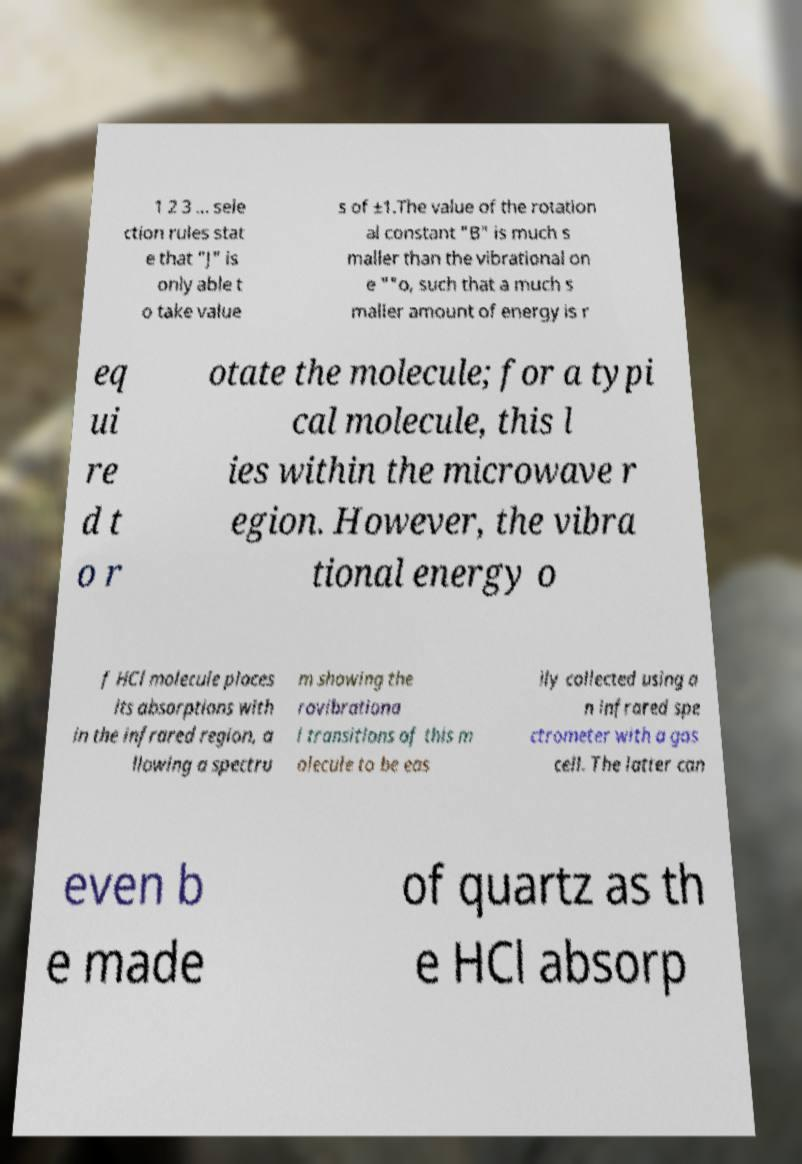Please identify and transcribe the text found in this image. 1 2 3 ... sele ction rules stat e that "J" is only able t o take value s of ±1.The value of the rotation al constant "B" is much s maller than the vibrational on e ""o, such that a much s maller amount of energy is r eq ui re d t o r otate the molecule; for a typi cal molecule, this l ies within the microwave r egion. However, the vibra tional energy o f HCl molecule places its absorptions with in the infrared region, a llowing a spectru m showing the rovibrationa l transitions of this m olecule to be eas ily collected using a n infrared spe ctrometer with a gas cell. The latter can even b e made of quartz as th e HCl absorp 